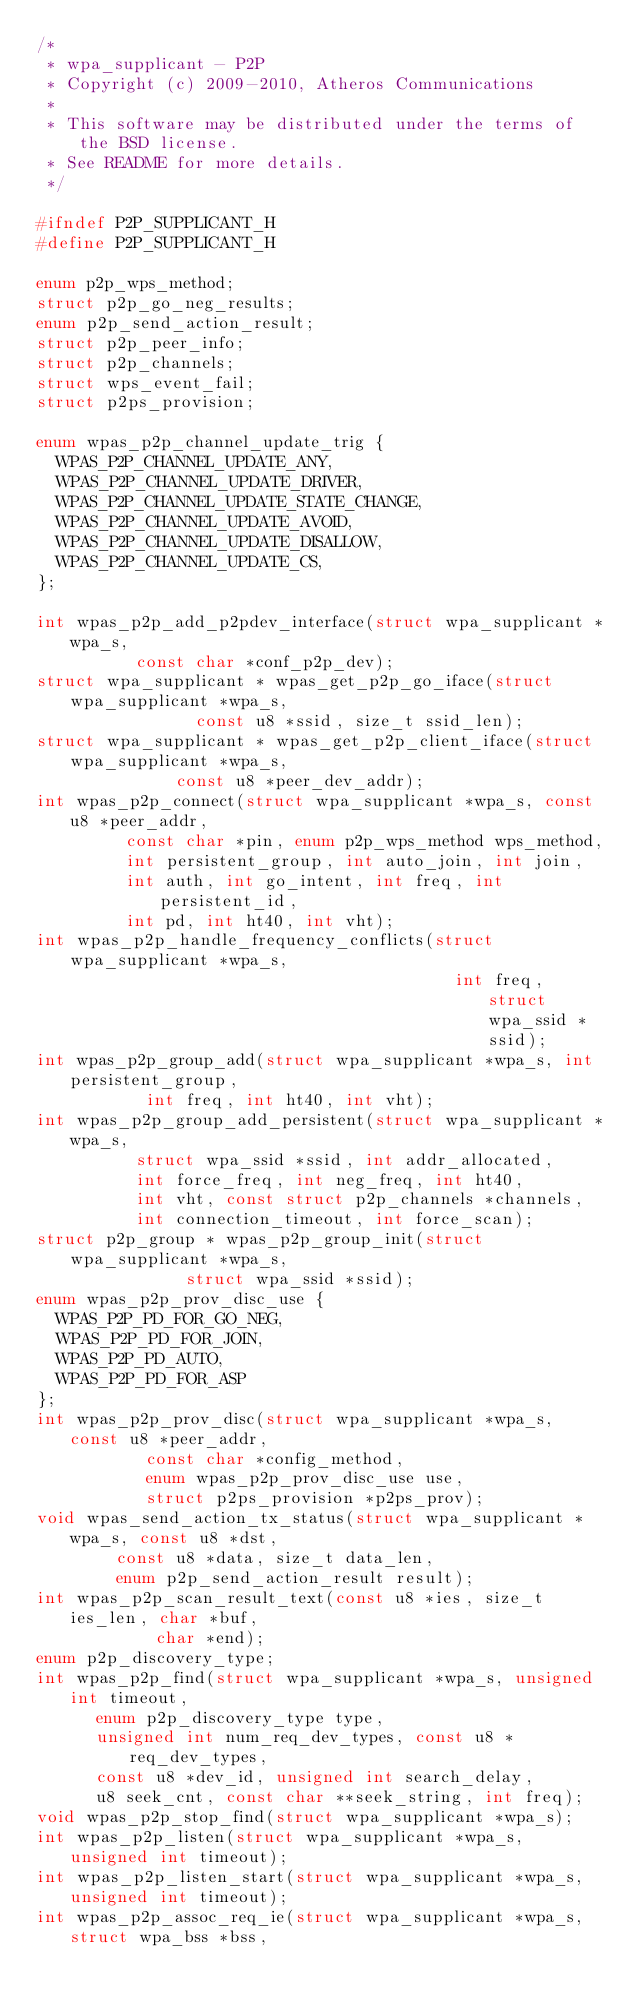Convert code to text. <code><loc_0><loc_0><loc_500><loc_500><_C_>/*
 * wpa_supplicant - P2P
 * Copyright (c) 2009-2010, Atheros Communications
 *
 * This software may be distributed under the terms of the BSD license.
 * See README for more details.
 */

#ifndef P2P_SUPPLICANT_H
#define P2P_SUPPLICANT_H

enum p2p_wps_method;
struct p2p_go_neg_results;
enum p2p_send_action_result;
struct p2p_peer_info;
struct p2p_channels;
struct wps_event_fail;
struct p2ps_provision;

enum wpas_p2p_channel_update_trig {
	WPAS_P2P_CHANNEL_UPDATE_ANY,
	WPAS_P2P_CHANNEL_UPDATE_DRIVER,
	WPAS_P2P_CHANNEL_UPDATE_STATE_CHANGE,
	WPAS_P2P_CHANNEL_UPDATE_AVOID,
	WPAS_P2P_CHANNEL_UPDATE_DISALLOW,
	WPAS_P2P_CHANNEL_UPDATE_CS,
};

int wpas_p2p_add_p2pdev_interface(struct wpa_supplicant *wpa_s,
				  const char *conf_p2p_dev);
struct wpa_supplicant * wpas_get_p2p_go_iface(struct wpa_supplicant *wpa_s,
					      const u8 *ssid, size_t ssid_len);
struct wpa_supplicant * wpas_get_p2p_client_iface(struct wpa_supplicant *wpa_s,
						  const u8 *peer_dev_addr);
int wpas_p2p_connect(struct wpa_supplicant *wpa_s, const u8 *peer_addr,
		     const char *pin, enum p2p_wps_method wps_method,
		     int persistent_group, int auto_join, int join,
		     int auth, int go_intent, int freq, int persistent_id,
		     int pd, int ht40, int vht);
int wpas_p2p_handle_frequency_conflicts(struct wpa_supplicant *wpa_s,
                                          int freq, struct wpa_ssid *ssid);
int wpas_p2p_group_add(struct wpa_supplicant *wpa_s, int persistent_group,
		       int freq, int ht40, int vht);
int wpas_p2p_group_add_persistent(struct wpa_supplicant *wpa_s,
				  struct wpa_ssid *ssid, int addr_allocated,
				  int force_freq, int neg_freq, int ht40,
				  int vht, const struct p2p_channels *channels,
				  int connection_timeout, int force_scan);
struct p2p_group * wpas_p2p_group_init(struct wpa_supplicant *wpa_s,
				       struct wpa_ssid *ssid);
enum wpas_p2p_prov_disc_use {
	WPAS_P2P_PD_FOR_GO_NEG,
	WPAS_P2P_PD_FOR_JOIN,
	WPAS_P2P_PD_AUTO,
	WPAS_P2P_PD_FOR_ASP
};
int wpas_p2p_prov_disc(struct wpa_supplicant *wpa_s, const u8 *peer_addr,
		       const char *config_method,
		       enum wpas_p2p_prov_disc_use use,
		       struct p2ps_provision *p2ps_prov);
void wpas_send_action_tx_status(struct wpa_supplicant *wpa_s, const u8 *dst,
				const u8 *data, size_t data_len,
				enum p2p_send_action_result result);
int wpas_p2p_scan_result_text(const u8 *ies, size_t ies_len, char *buf,
			      char *end);
enum p2p_discovery_type;
int wpas_p2p_find(struct wpa_supplicant *wpa_s, unsigned int timeout,
		  enum p2p_discovery_type type,
		  unsigned int num_req_dev_types, const u8 *req_dev_types,
		  const u8 *dev_id, unsigned int search_delay,
		  u8 seek_cnt, const char **seek_string, int freq);
void wpas_p2p_stop_find(struct wpa_supplicant *wpa_s);
int wpas_p2p_listen(struct wpa_supplicant *wpa_s, unsigned int timeout);
int wpas_p2p_listen_start(struct wpa_supplicant *wpa_s, unsigned int timeout);
int wpas_p2p_assoc_req_ie(struct wpa_supplicant *wpa_s, struct wpa_bss *bss,</code> 